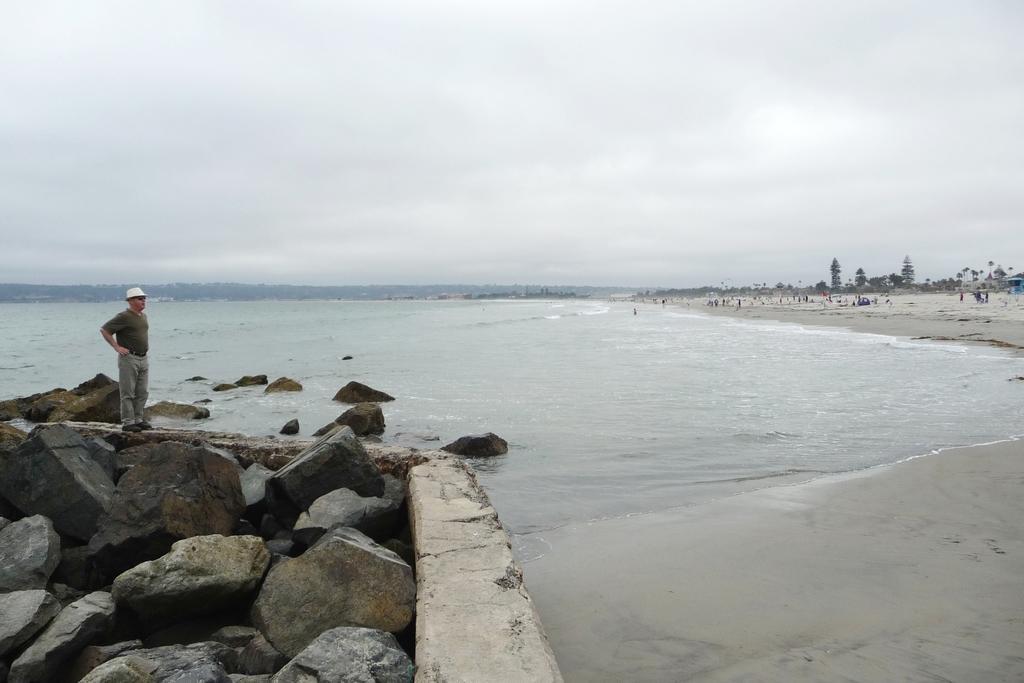Could you give a brief overview of what you see in this image? In this picture there is a man on the left side of the image, on the rocks and there is water in the center of the image, there are trees on the right side of the image. 